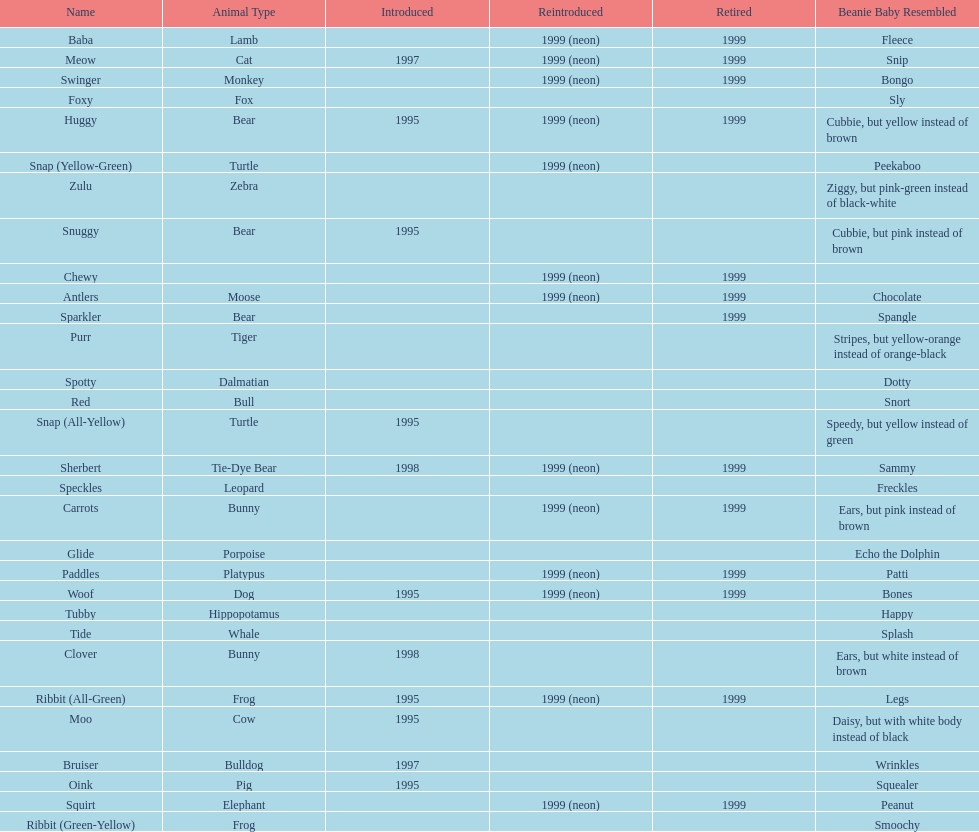Which animal type has the most pillow pals? Bear. 